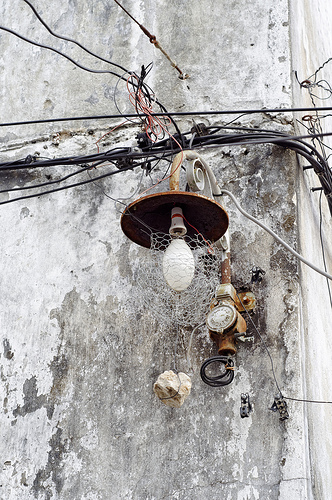<image>
Is the light on the wall? Yes. Looking at the image, I can see the light is positioned on top of the wall, with the wall providing support. Is the bulb on the stone? No. The bulb is not positioned on the stone. They may be near each other, but the bulb is not supported by or resting on top of the stone. 